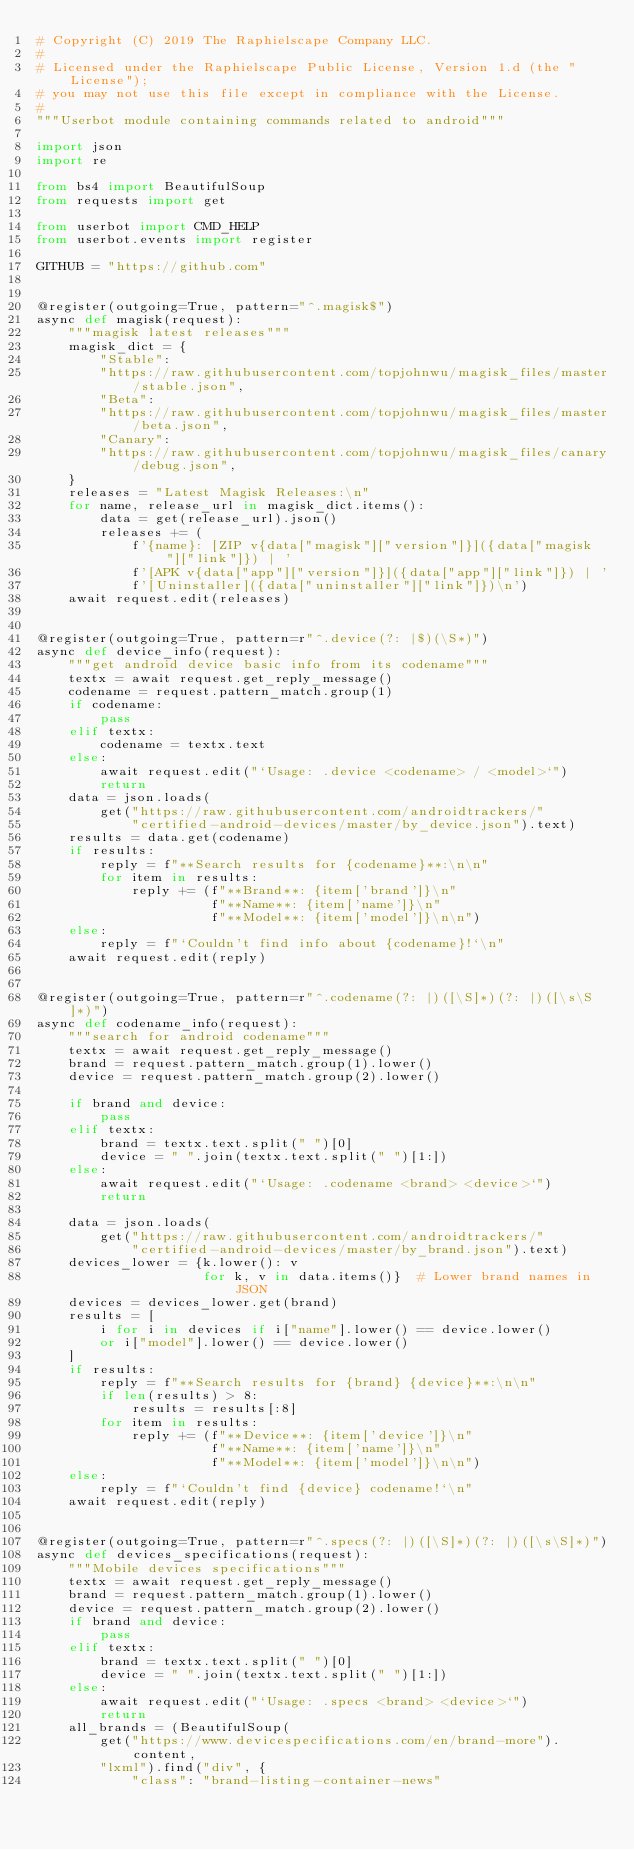Convert code to text. <code><loc_0><loc_0><loc_500><loc_500><_Python_># Copyright (C) 2019 The Raphielscape Company LLC.
#
# Licensed under the Raphielscape Public License, Version 1.d (the "License");
# you may not use this file except in compliance with the License.
#
"""Userbot module containing commands related to android"""

import json
import re

from bs4 import BeautifulSoup
from requests import get

from userbot import CMD_HELP
from userbot.events import register

GITHUB = "https://github.com"


@register(outgoing=True, pattern="^.magisk$")
async def magisk(request):
    """magisk latest releases"""
    magisk_dict = {
        "Stable":
        "https://raw.githubusercontent.com/topjohnwu/magisk_files/master/stable.json",
        "Beta":
        "https://raw.githubusercontent.com/topjohnwu/magisk_files/master/beta.json",
        "Canary":
        "https://raw.githubusercontent.com/topjohnwu/magisk_files/canary/debug.json",
    }
    releases = "Latest Magisk Releases:\n"
    for name, release_url in magisk_dict.items():
        data = get(release_url).json()
        releases += (
            f'{name}: [ZIP v{data["magisk"]["version"]}]({data["magisk"]["link"]}) | '
            f'[APK v{data["app"]["version"]}]({data["app"]["link"]}) | '
            f'[Uninstaller]({data["uninstaller"]["link"]})\n')
    await request.edit(releases)


@register(outgoing=True, pattern=r"^.device(?: |$)(\S*)")
async def device_info(request):
    """get android device basic info from its codename"""
    textx = await request.get_reply_message()
    codename = request.pattern_match.group(1)
    if codename:
        pass
    elif textx:
        codename = textx.text
    else:
        await request.edit("`Usage: .device <codename> / <model>`")
        return
    data = json.loads(
        get("https://raw.githubusercontent.com/androidtrackers/"
            "certified-android-devices/master/by_device.json").text)
    results = data.get(codename)
    if results:
        reply = f"**Search results for {codename}**:\n\n"
        for item in results:
            reply += (f"**Brand**: {item['brand']}\n"
                      f"**Name**: {item['name']}\n"
                      f"**Model**: {item['model']}\n\n")
    else:
        reply = f"`Couldn't find info about {codename}!`\n"
    await request.edit(reply)


@register(outgoing=True, pattern=r"^.codename(?: |)([\S]*)(?: |)([\s\S]*)")
async def codename_info(request):
    """search for android codename"""
    textx = await request.get_reply_message()
    brand = request.pattern_match.group(1).lower()
    device = request.pattern_match.group(2).lower()

    if brand and device:
        pass
    elif textx:
        brand = textx.text.split(" ")[0]
        device = " ".join(textx.text.split(" ")[1:])
    else:
        await request.edit("`Usage: .codename <brand> <device>`")
        return

    data = json.loads(
        get("https://raw.githubusercontent.com/androidtrackers/"
            "certified-android-devices/master/by_brand.json").text)
    devices_lower = {k.lower(): v
                     for k, v in data.items()}  # Lower brand names in JSON
    devices = devices_lower.get(brand)
    results = [
        i for i in devices if i["name"].lower() == device.lower()
        or i["model"].lower() == device.lower()
    ]
    if results:
        reply = f"**Search results for {brand} {device}**:\n\n"
        if len(results) > 8:
            results = results[:8]
        for item in results:
            reply += (f"**Device**: {item['device']}\n"
                      f"**Name**: {item['name']}\n"
                      f"**Model**: {item['model']}\n\n")
    else:
        reply = f"`Couldn't find {device} codename!`\n"
    await request.edit(reply)


@register(outgoing=True, pattern=r"^.specs(?: |)([\S]*)(?: |)([\s\S]*)")
async def devices_specifications(request):
    """Mobile devices specifications"""
    textx = await request.get_reply_message()
    brand = request.pattern_match.group(1).lower()
    device = request.pattern_match.group(2).lower()
    if brand and device:
        pass
    elif textx:
        brand = textx.text.split(" ")[0]
        device = " ".join(textx.text.split(" ")[1:])
    else:
        await request.edit("`Usage: .specs <brand> <device>`")
        return
    all_brands = (BeautifulSoup(
        get("https://www.devicespecifications.com/en/brand-more").content,
        "lxml").find("div", {
            "class": "brand-listing-container-news"</code> 